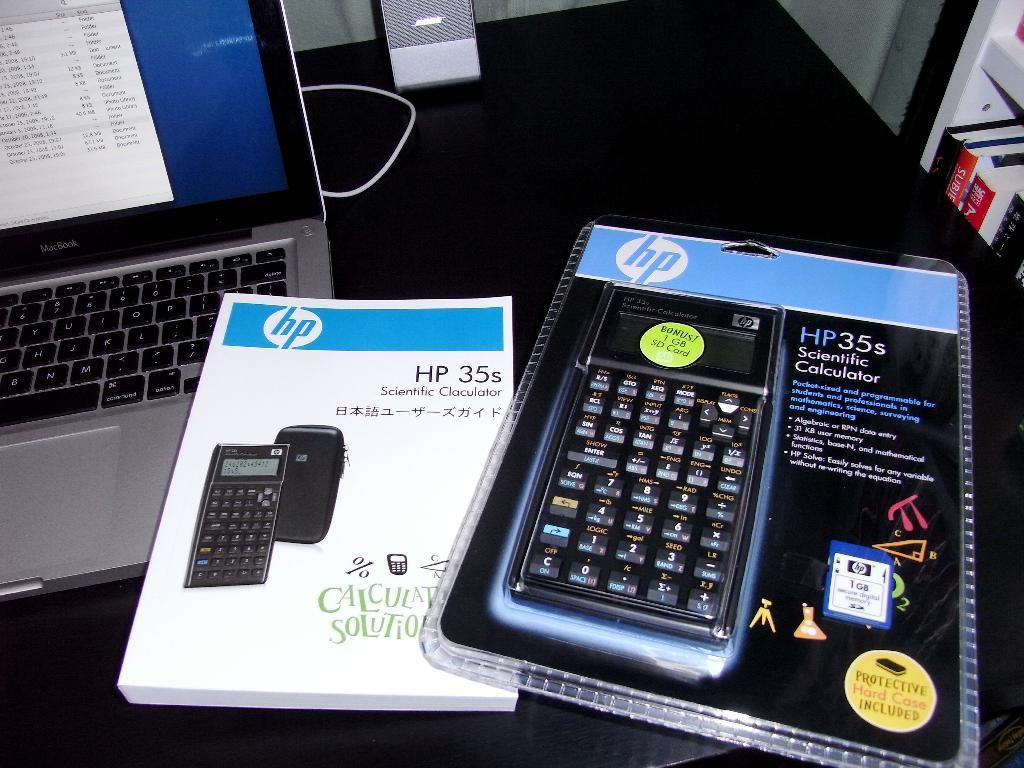What piece of furniture is present in the image? There is a table in the image. What electronic device is on the table? There is a laptop on the table. What other object is on the table? There is a calculator and a book on the table. What can be seen on the shelves next to the table? There are shelves with books next to the table. What type of shade is being used to cover the window in the image? There is no window or shade present in the image. What type of curtain is hanging next to the table in the image? There is no curtain present in the image. 